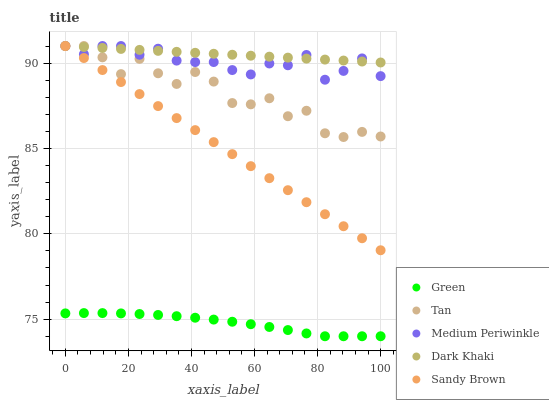Does Green have the minimum area under the curve?
Answer yes or no. Yes. Does Dark Khaki have the maximum area under the curve?
Answer yes or no. Yes. Does Medium Periwinkle have the minimum area under the curve?
Answer yes or no. No. Does Medium Periwinkle have the maximum area under the curve?
Answer yes or no. No. Is Sandy Brown the smoothest?
Answer yes or no. Yes. Is Tan the roughest?
Answer yes or no. Yes. Is Medium Periwinkle the smoothest?
Answer yes or no. No. Is Medium Periwinkle the roughest?
Answer yes or no. No. Does Green have the lowest value?
Answer yes or no. Yes. Does Medium Periwinkle have the lowest value?
Answer yes or no. No. Does Sandy Brown have the highest value?
Answer yes or no. Yes. Does Green have the highest value?
Answer yes or no. No. Is Green less than Medium Periwinkle?
Answer yes or no. Yes. Is Medium Periwinkle greater than Green?
Answer yes or no. Yes. Does Medium Periwinkle intersect Tan?
Answer yes or no. Yes. Is Medium Periwinkle less than Tan?
Answer yes or no. No. Is Medium Periwinkle greater than Tan?
Answer yes or no. No. Does Green intersect Medium Periwinkle?
Answer yes or no. No. 